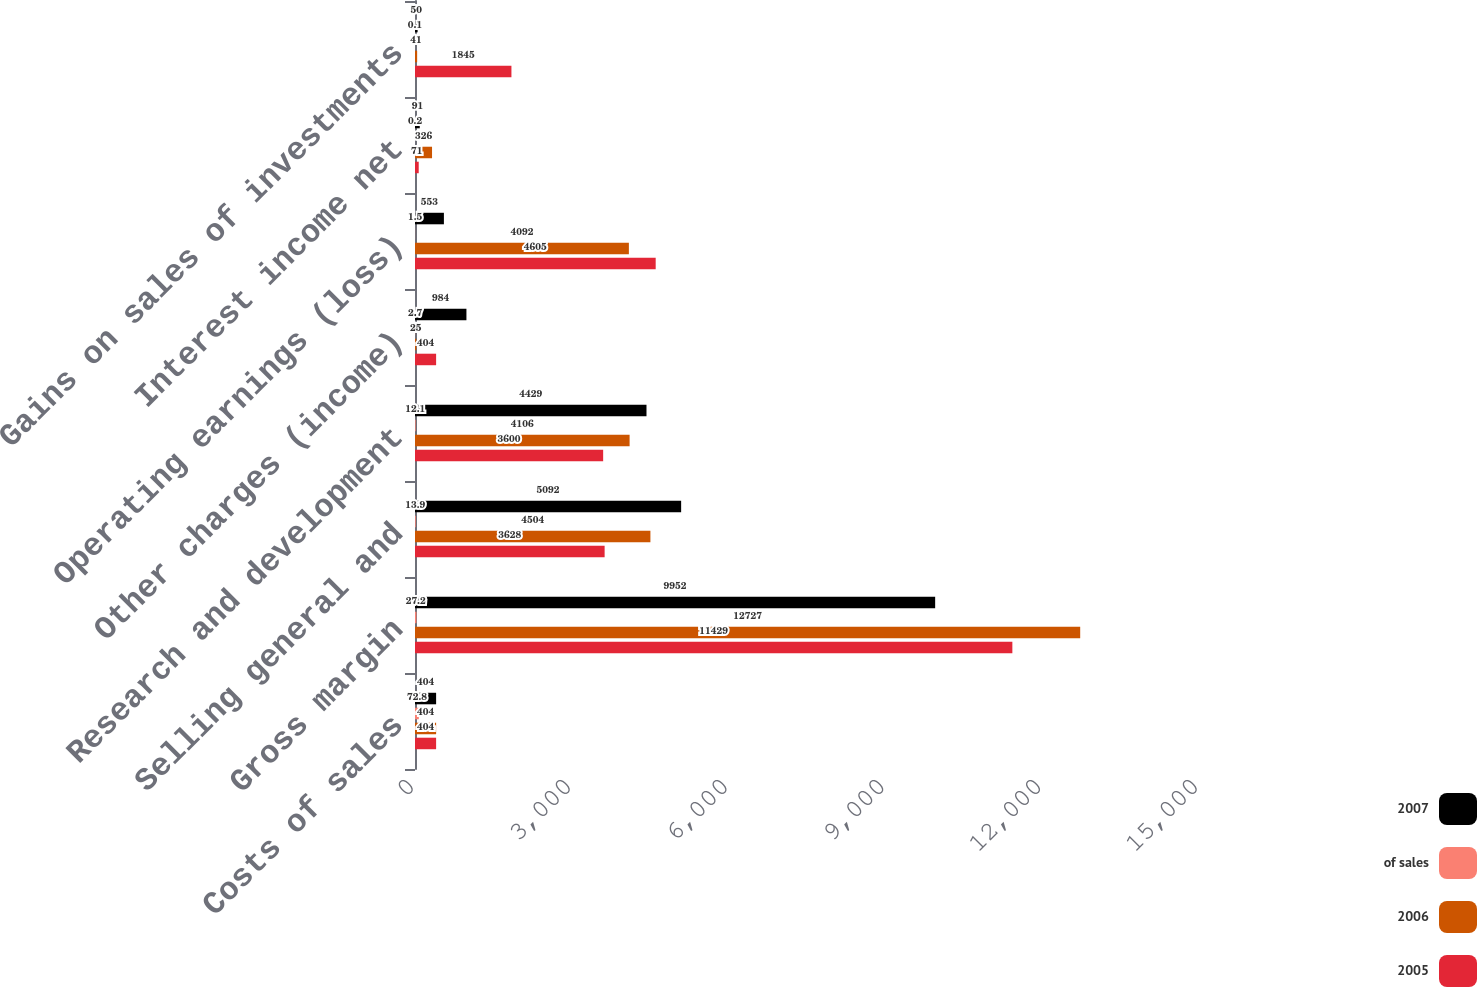<chart> <loc_0><loc_0><loc_500><loc_500><stacked_bar_chart><ecel><fcel>Costs of sales<fcel>Gross margin<fcel>Selling general and<fcel>Research and development<fcel>Other charges (income)<fcel>Operating earnings (loss)<fcel>Interest income net<fcel>Gains on sales of investments<nl><fcel>2007<fcel>404<fcel>9952<fcel>5092<fcel>4429<fcel>984<fcel>553<fcel>91<fcel>50<nl><fcel>of sales<fcel>72.8<fcel>27.2<fcel>13.9<fcel>12.1<fcel>2.7<fcel>1.5<fcel>0.2<fcel>0.1<nl><fcel>2006<fcel>404<fcel>12727<fcel>4504<fcel>4106<fcel>25<fcel>4092<fcel>326<fcel>41<nl><fcel>2005<fcel>404<fcel>11429<fcel>3628<fcel>3600<fcel>404<fcel>4605<fcel>71<fcel>1845<nl></chart> 